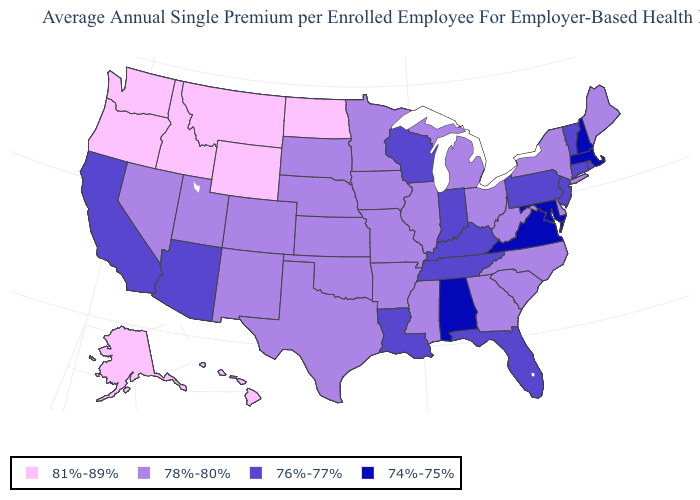Among the states that border Mississippi , which have the highest value?
Answer briefly. Arkansas. How many symbols are there in the legend?
Keep it brief. 4. What is the lowest value in the Northeast?
Quick response, please. 74%-75%. Is the legend a continuous bar?
Give a very brief answer. No. Name the states that have a value in the range 76%-77%?
Keep it brief. Arizona, California, Connecticut, Florida, Indiana, Kentucky, Louisiana, New Jersey, Pennsylvania, Rhode Island, Tennessee, Vermont, Wisconsin. Which states have the lowest value in the West?
Write a very short answer. Arizona, California. Which states have the highest value in the USA?
Write a very short answer. Alaska, Hawaii, Idaho, Montana, North Dakota, Oregon, Washington, Wyoming. How many symbols are there in the legend?
Answer briefly. 4. What is the value of South Carolina?
Concise answer only. 78%-80%. Which states have the lowest value in the Northeast?
Answer briefly. Massachusetts, New Hampshire. Does Utah have the highest value in the West?
Write a very short answer. No. Among the states that border Indiana , which have the highest value?
Short answer required. Illinois, Michigan, Ohio. Name the states that have a value in the range 76%-77%?
Quick response, please. Arizona, California, Connecticut, Florida, Indiana, Kentucky, Louisiana, New Jersey, Pennsylvania, Rhode Island, Tennessee, Vermont, Wisconsin. Does Idaho have the same value as New York?
Concise answer only. No. Does the first symbol in the legend represent the smallest category?
Quick response, please. No. 